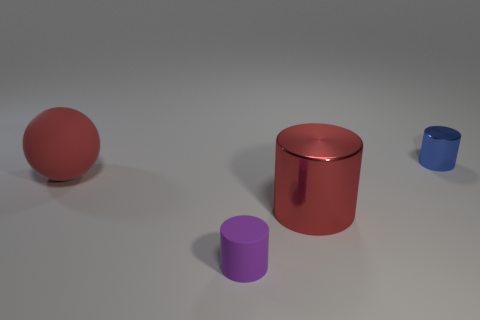How many small yellow metallic blocks are there?
Your answer should be compact. 0. There is a thing that is both on the left side of the red shiny cylinder and behind the purple thing; how big is it?
Your answer should be very brief. Large. What shape is the thing that is the same size as the blue cylinder?
Make the answer very short. Cylinder. Is there a big red rubber ball to the left of the rubber thing that is in front of the large red rubber sphere?
Ensure brevity in your answer.  Yes. There is a large object that is the same shape as the small purple matte thing; what is its color?
Ensure brevity in your answer.  Red. There is a metal object in front of the large red matte thing; does it have the same color as the rubber sphere?
Give a very brief answer. Yes. What number of objects are either tiny things in front of the red rubber sphere or large yellow matte cubes?
Ensure brevity in your answer.  1. There is a big object that is left of the tiny object that is on the left side of the tiny cylinder behind the purple object; what is its material?
Your answer should be compact. Rubber. Is the number of purple rubber cylinders to the left of the small rubber cylinder greater than the number of metallic things that are behind the sphere?
Make the answer very short. No. How many cubes are either tiny blue objects or metal things?
Give a very brief answer. 0. 